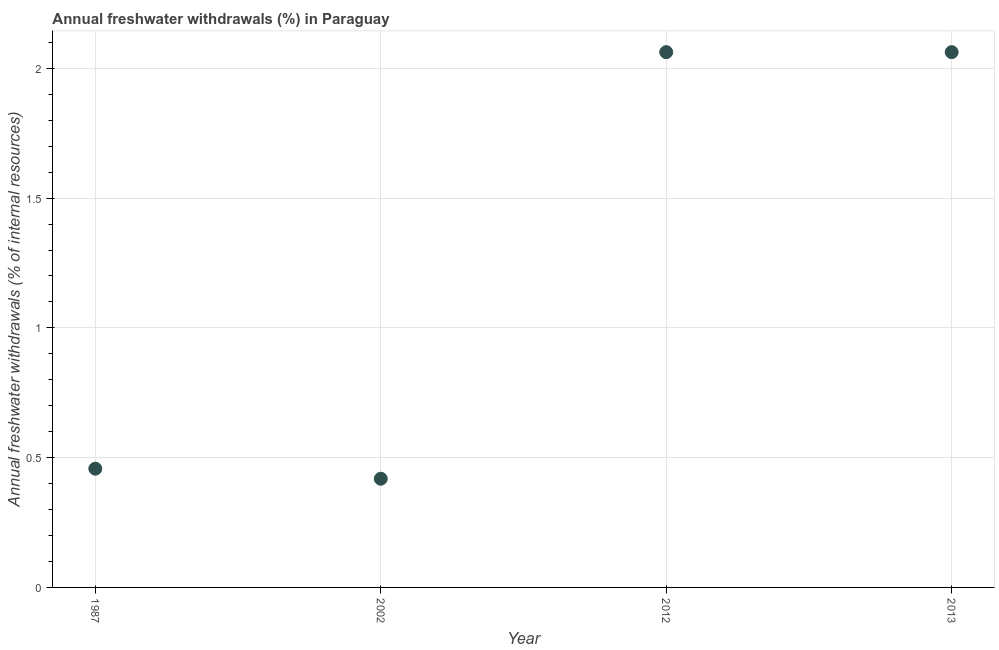What is the annual freshwater withdrawals in 2012?
Give a very brief answer. 2.06. Across all years, what is the maximum annual freshwater withdrawals?
Offer a terse response. 2.06. Across all years, what is the minimum annual freshwater withdrawals?
Provide a succinct answer. 0.42. What is the sum of the annual freshwater withdrawals?
Your answer should be very brief. 5. What is the difference between the annual freshwater withdrawals in 2002 and 2012?
Offer a terse response. -1.64. What is the average annual freshwater withdrawals per year?
Offer a terse response. 1.25. What is the median annual freshwater withdrawals?
Your answer should be compact. 1.26. What is the ratio of the annual freshwater withdrawals in 2002 to that in 2012?
Keep it short and to the point. 0.2. Is the annual freshwater withdrawals in 1987 less than that in 2013?
Provide a short and direct response. Yes. Is the difference between the annual freshwater withdrawals in 2002 and 2013 greater than the difference between any two years?
Provide a short and direct response. Yes. What is the difference between the highest and the second highest annual freshwater withdrawals?
Offer a very short reply. 0. What is the difference between the highest and the lowest annual freshwater withdrawals?
Give a very brief answer. 1.64. How many dotlines are there?
Offer a terse response. 1. How many years are there in the graph?
Provide a succinct answer. 4. Does the graph contain any zero values?
Make the answer very short. No. What is the title of the graph?
Offer a terse response. Annual freshwater withdrawals (%) in Paraguay. What is the label or title of the X-axis?
Give a very brief answer. Year. What is the label or title of the Y-axis?
Give a very brief answer. Annual freshwater withdrawals (% of internal resources). What is the Annual freshwater withdrawals (% of internal resources) in 1987?
Give a very brief answer. 0.46. What is the Annual freshwater withdrawals (% of internal resources) in 2002?
Keep it short and to the point. 0.42. What is the Annual freshwater withdrawals (% of internal resources) in 2012?
Provide a short and direct response. 2.06. What is the Annual freshwater withdrawals (% of internal resources) in 2013?
Your answer should be compact. 2.06. What is the difference between the Annual freshwater withdrawals (% of internal resources) in 1987 and 2002?
Your answer should be very brief. 0.04. What is the difference between the Annual freshwater withdrawals (% of internal resources) in 1987 and 2012?
Provide a short and direct response. -1.6. What is the difference between the Annual freshwater withdrawals (% of internal resources) in 1987 and 2013?
Keep it short and to the point. -1.6. What is the difference between the Annual freshwater withdrawals (% of internal resources) in 2002 and 2012?
Your answer should be very brief. -1.64. What is the difference between the Annual freshwater withdrawals (% of internal resources) in 2002 and 2013?
Make the answer very short. -1.64. What is the ratio of the Annual freshwater withdrawals (% of internal resources) in 1987 to that in 2002?
Your answer should be compact. 1.09. What is the ratio of the Annual freshwater withdrawals (% of internal resources) in 1987 to that in 2012?
Offer a very short reply. 0.22. What is the ratio of the Annual freshwater withdrawals (% of internal resources) in 1987 to that in 2013?
Make the answer very short. 0.22. What is the ratio of the Annual freshwater withdrawals (% of internal resources) in 2002 to that in 2012?
Give a very brief answer. 0.2. What is the ratio of the Annual freshwater withdrawals (% of internal resources) in 2002 to that in 2013?
Make the answer very short. 0.2. 